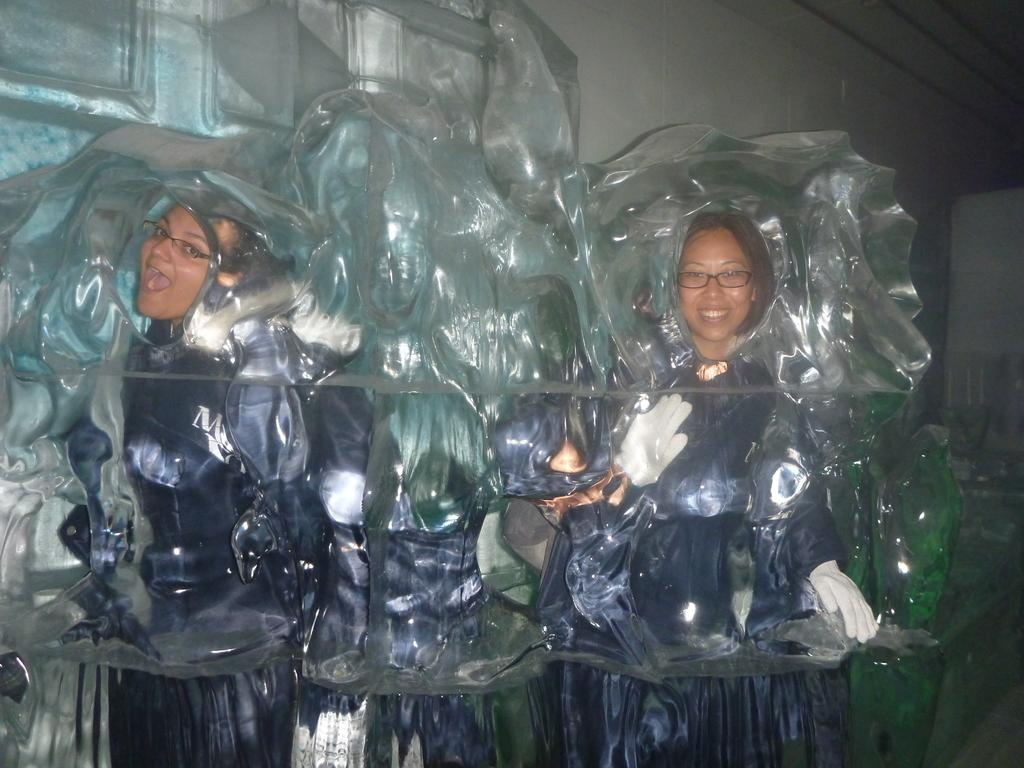How many women are in the image? There are two women in the image. What is the facial expression of the woman on the right? The woman on the right is smiling. Can you describe the object that resembles a mold-like in the image? Yes, there is an object that looks like a mold-like in the image. What is visible in the background of the image? There is a wall in the background of the image. What type of sticks can be seen in the image? There are no sticks visible in the image. What color is the polish on the woman's nails in the image? The image does not show the women's nails or any polish on them. 